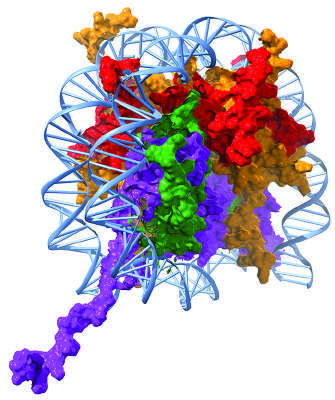what are positively charged, thus allowing the compaction of the negatively charged dna?
Answer the question using a single word or phrase. The histone subunits 